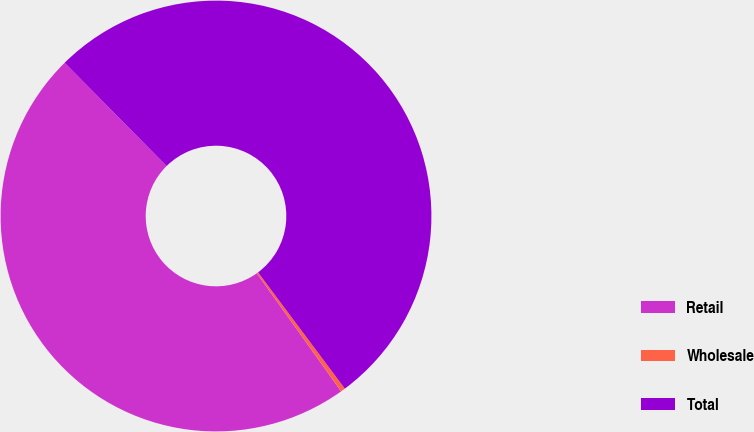Convert chart. <chart><loc_0><loc_0><loc_500><loc_500><pie_chart><fcel>Retail<fcel>Wholesale<fcel>Total<nl><fcel>47.46%<fcel>0.34%<fcel>52.2%<nl></chart> 